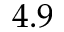Convert formula to latex. <formula><loc_0><loc_0><loc_500><loc_500>4 . 9</formula> 